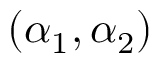<formula> <loc_0><loc_0><loc_500><loc_500>( \alpha _ { 1 } , \alpha _ { 2 } )</formula> 